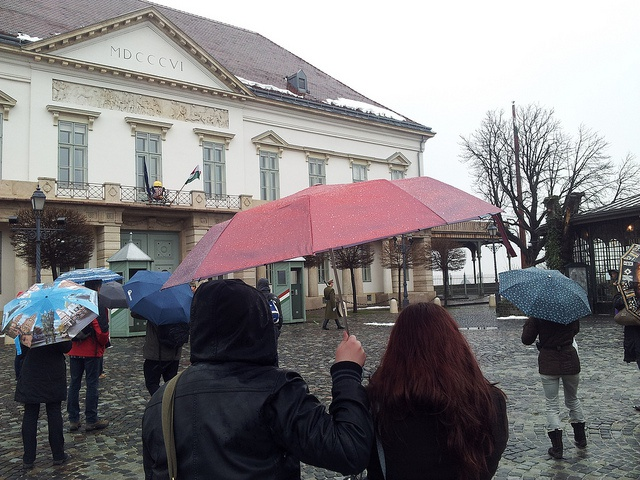Describe the objects in this image and their specific colors. I can see people in gray and black tones, people in gray and black tones, umbrella in gray, lightpink, and salmon tones, people in gray, black, and darkgray tones, and umbrella in gray, lightblue, and darkgray tones in this image. 